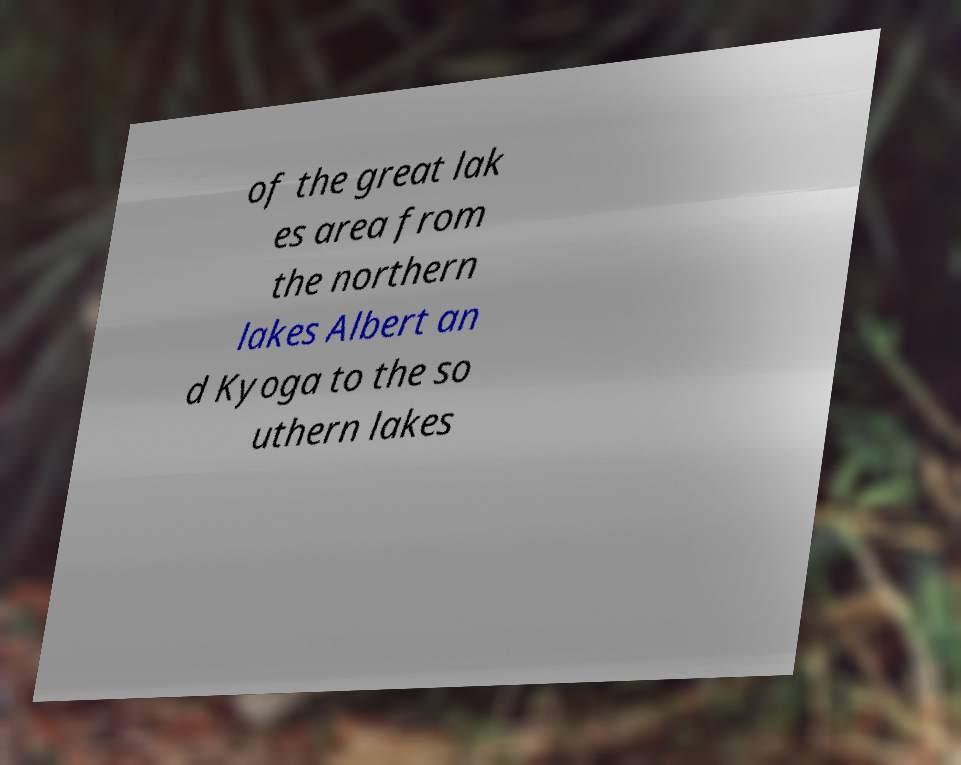Please identify and transcribe the text found in this image. of the great lak es area from the northern lakes Albert an d Kyoga to the so uthern lakes 